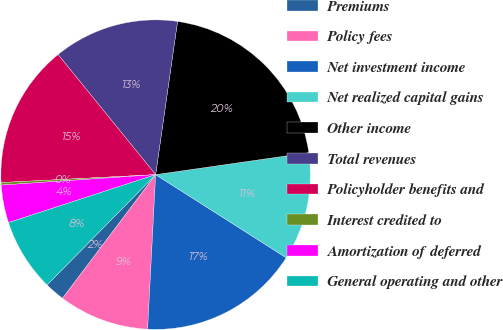Convert chart. <chart><loc_0><loc_0><loc_500><loc_500><pie_chart><fcel>Premiums<fcel>Policy fees<fcel>Net investment income<fcel>Net realized capital gains<fcel>Other income<fcel>Total revenues<fcel>Policyholder benefits and<fcel>Interest credited to<fcel>Amortization of deferred<fcel>General operating and other<nl><fcel>2.1%<fcel>9.45%<fcel>16.8%<fcel>11.29%<fcel>20.47%<fcel>13.12%<fcel>14.96%<fcel>0.26%<fcel>3.94%<fcel>7.61%<nl></chart> 